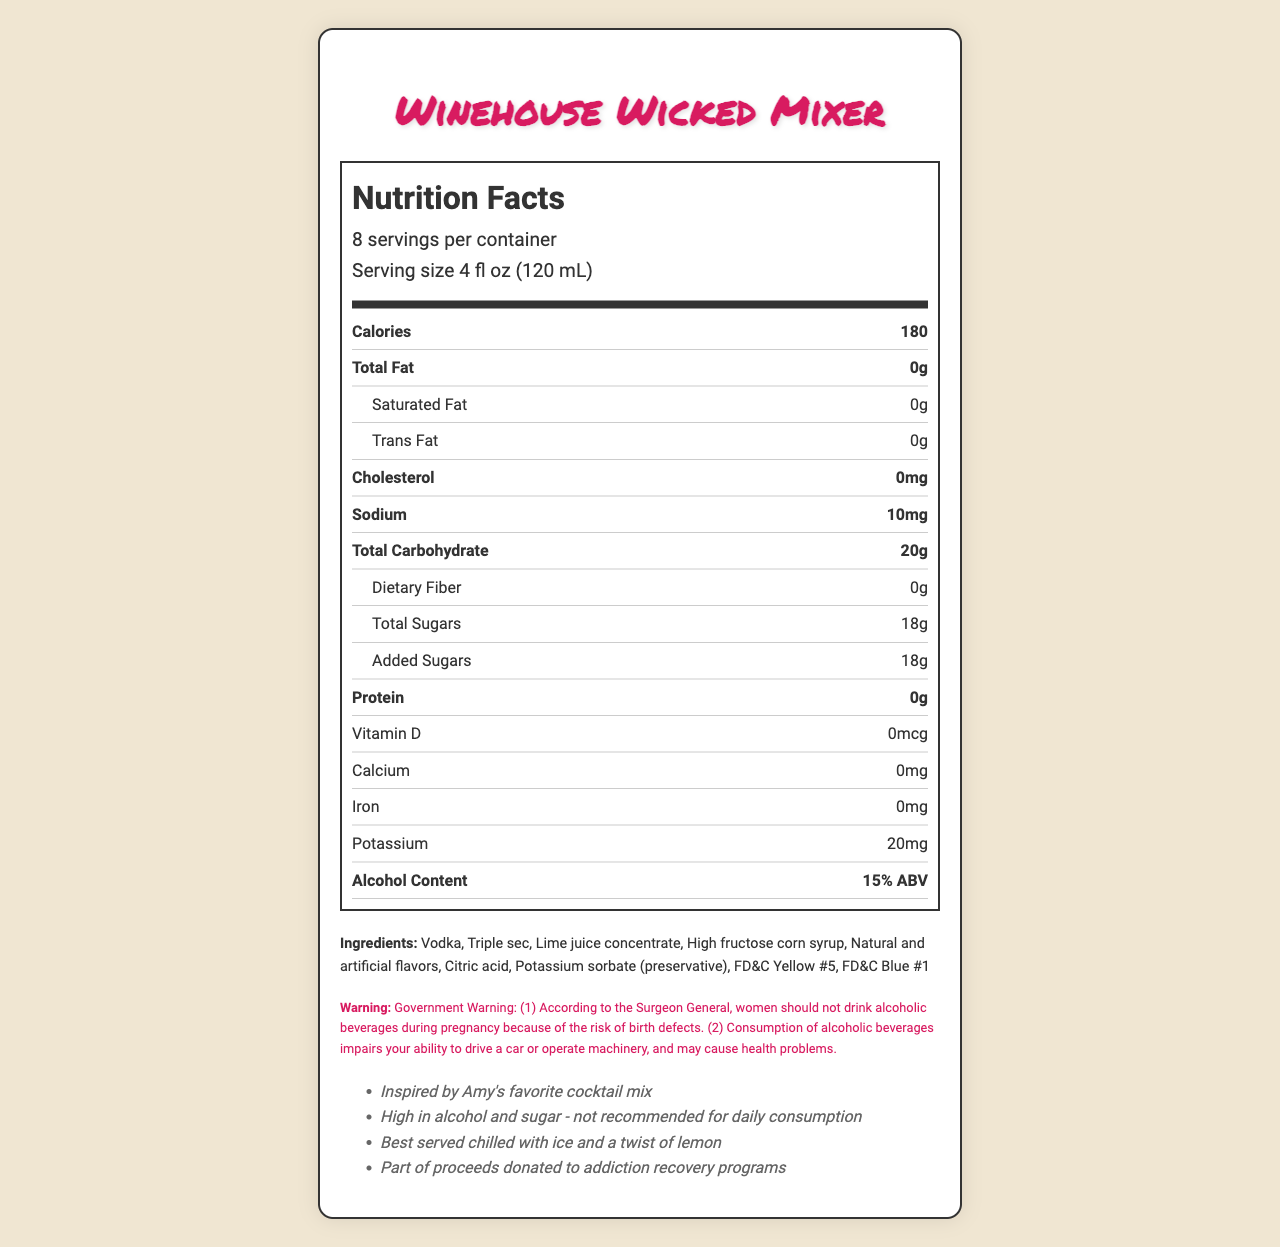What is the serving size of Winehouse Wicked Mixer? The serving size is listed at the top of the nutrition facts label as "4 fl oz (120 mL)".
Answer: 4 fl oz (120 mL) How many calories are in one serving? The calories per serving are listed in bold on the nutrition facts label as "180".
Answer: 180 How much total fat is in one serving? The total fat per serving is listed as "0g" on the nutrition facts label.
Answer: 0g Does Winehouse Wicked Mixer contain any dietary fiber? The dietary fiber is listed as "0g" on the nutrition facts label.
Answer: No What is the alcohol content of this mixer? The alcohol content is listed as "15% ABV" on the nutrition facts label.
Answer: 15% ABV What are the main ingredients in Winehouse Wicked Mixer? A. Vodka, Triple sec, Lime juice concentrate B. Orange juice, Vodka, High fructose corn syrup C. Vodka, Rum, Citric acid The listed ingredients include "Vodka, Triple sec, Lime juice concentrate, High fructose corn syrup, Natural and artificial flavors, Citric acid, Potassium sorbate (preservative), FD&C Yellow #5, FD&C Blue #1."
Answer: A Which of the following is a preservative used in Winehouse Wicked Mixer? A. Sodium chloride B. Potassium sorbate C. Calcium sorbate The ingredient list includes "Potassium sorbate (preservative)".
Answer: B Is this cocktail mixer safe for people with common food allergies? The allergen information states "Contains no known allergens".
Answer: Yes Describe the main idea of the nutrition facts label for Winehouse Wicked Mixer. The document comprehensively conveys information regarding the nutritional value, ingredients, and safety warnings for the Winehouse Wicked Mixer, emphasizing its high alcohol and sugar content.
Answer: The nutrition facts label provides detailed nutritional information about the Winehouse Wicked Mixer, including serving size, calorie content, the amount of fat, cholesterol, sodium, carbohydrates, sugars, protein, vitamins, and minerals. It also lists the alcohol content, ingredients, allergen information, a government warning, and additional notes about consumption and charity contributions. What is the total amount of sugar in one serving? The total sugars per serving are listed as "18g" on the nutrition facts label, with all of it being added sugars.
Answer: 18g How many servings are there per container? The servings per container are specified as "8" on the nutrition facts label.
Answer: 8 Can we determine the number of calories from alcohol specifically? The label provides the total calories per serving but does not break down the specific calories derived from alcohol.
Answer: Not enough information What is the sodium content per serving? The sodium content is listed as "10mg" on the nutrition facts label.
Answer: 10mg What is the recommended way to serve this mixer? The additional info section mentions that it is "Best served chilled with ice and a twist of lemon".
Answer: Best served chilled with ice and a twist of lemon Does the product support any charitable causes? The additional info states "Part of proceeds donated to addiction recovery programs".
Answer: Yes Is the nutrition facts label compliant with providing a government health warning? The document includes a government warning regarding the consumption of alcoholic beverages, including risks during pregnancy and impairments.
Answer: Yes What is the manufacturer of Winehouse Wicked Mixer? The manufacturer is listed as "Camden Town Spirits Ltd." on the nutrition facts label.
Answer: Camden Town Spirits Ltd. 